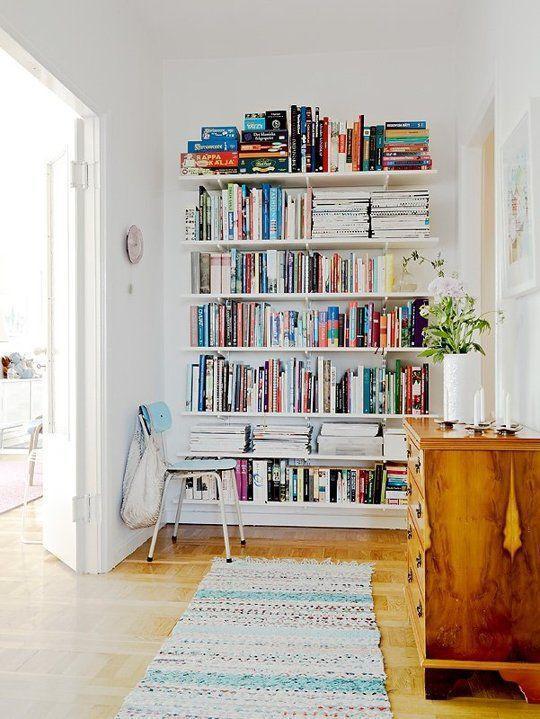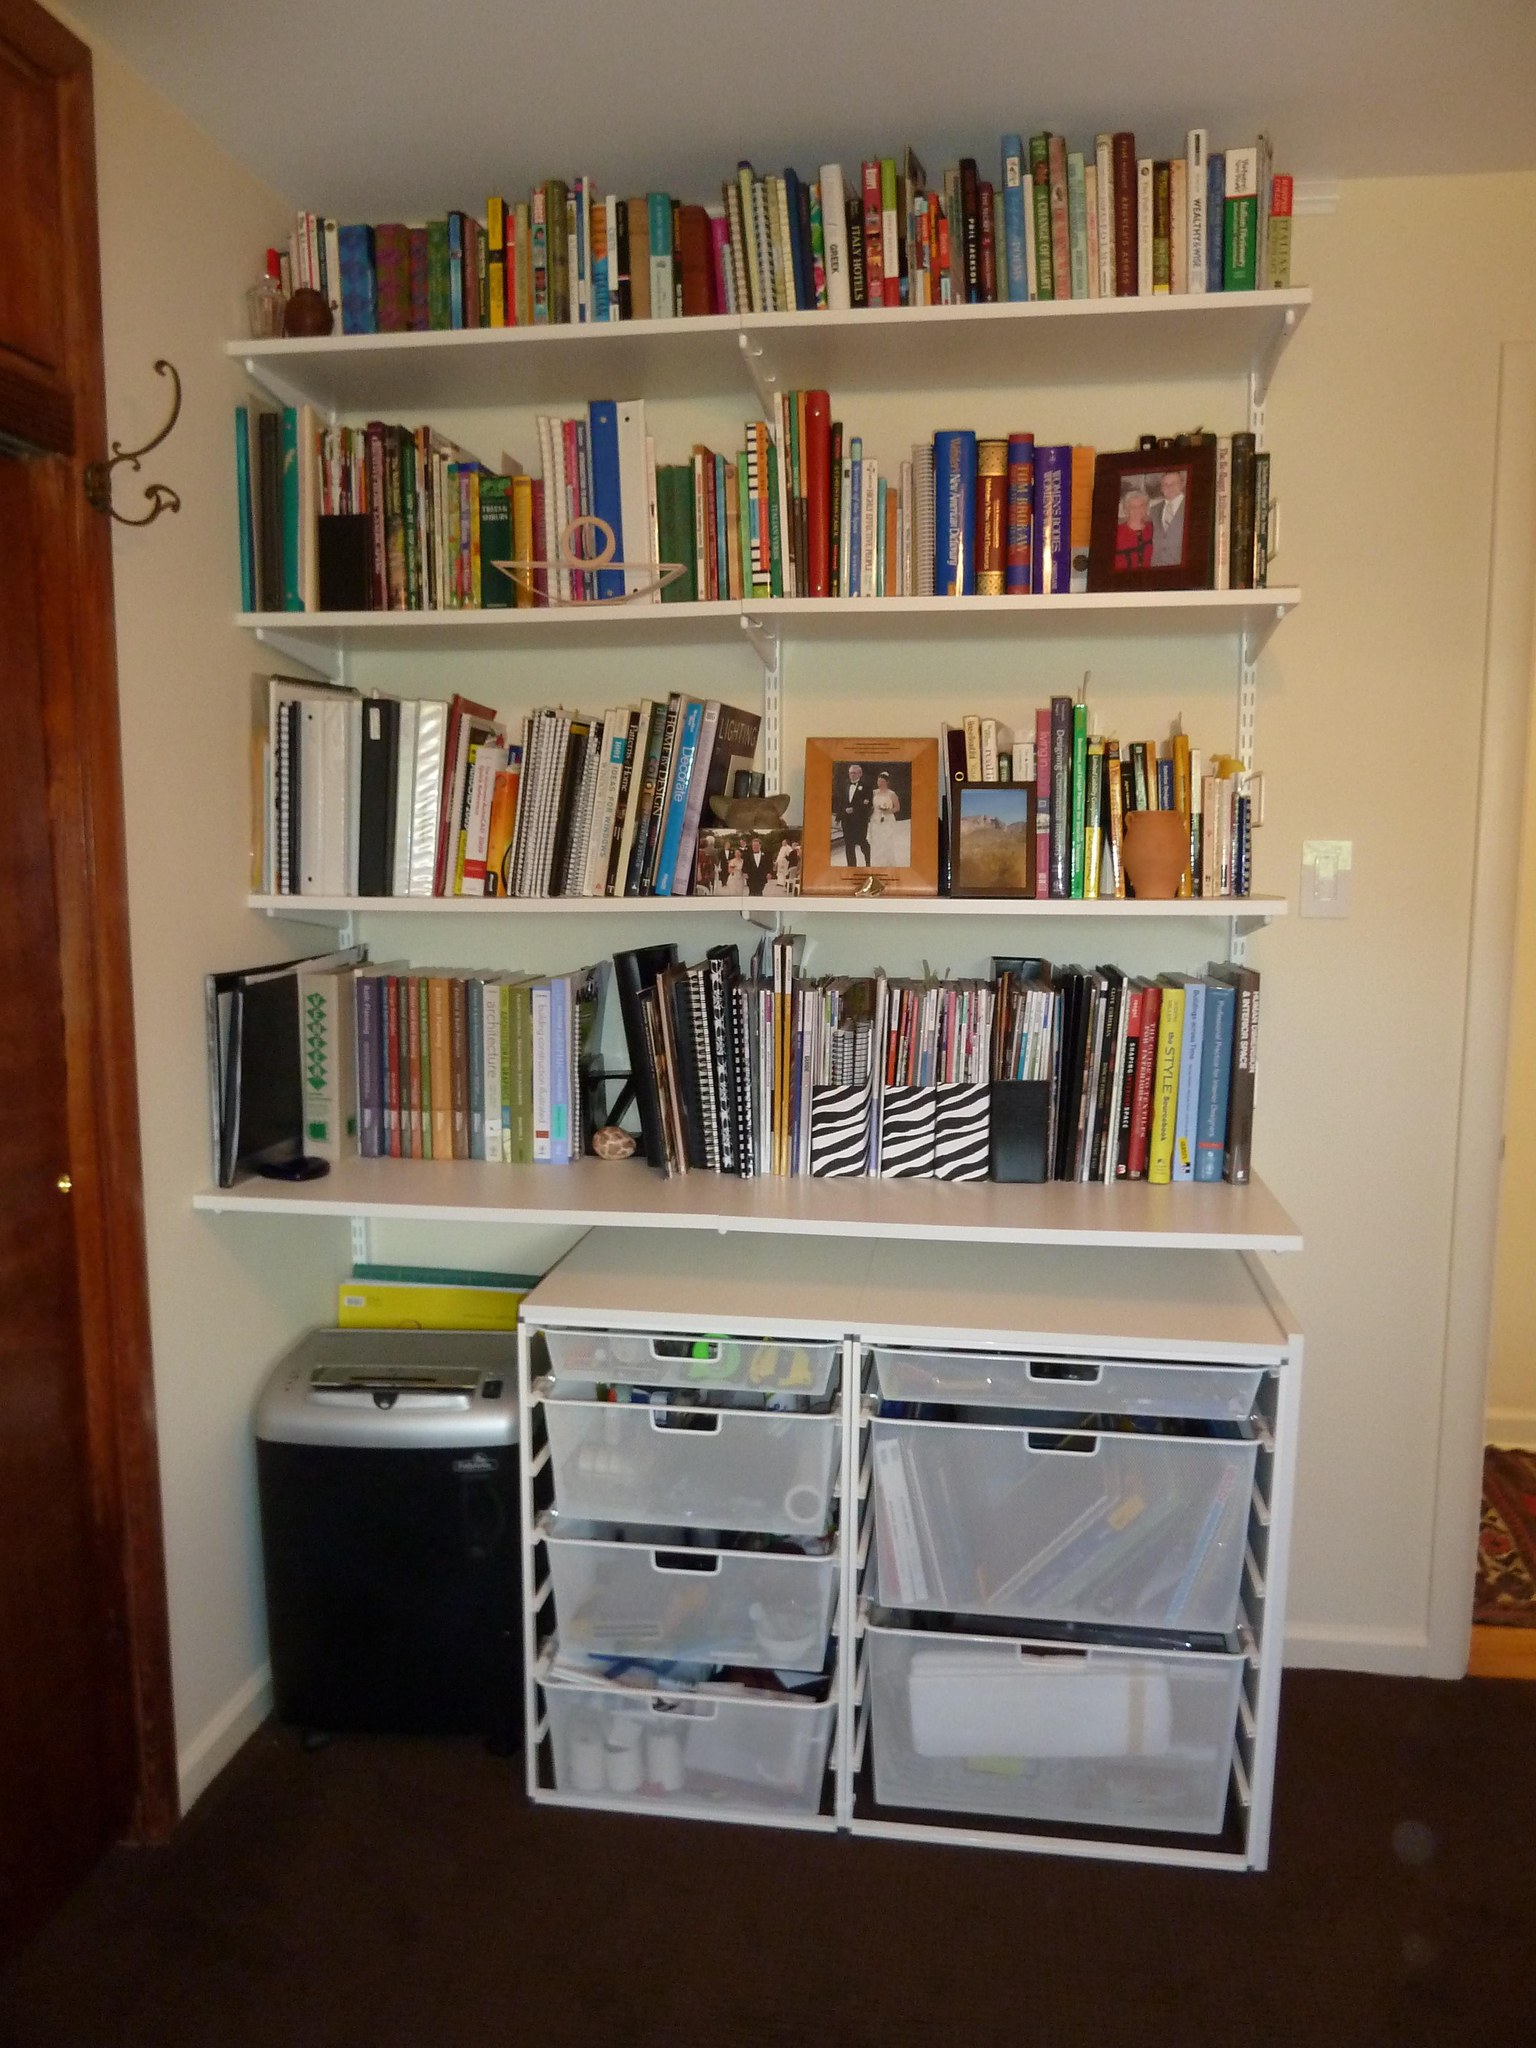The first image is the image on the left, the second image is the image on the right. Given the left and right images, does the statement "Both images show some type of floating white bookshelves that mount to the wall." hold true? Answer yes or no. Yes. The first image is the image on the left, the second image is the image on the right. Considering the images on both sides, is "There is at least one plant in the pair of images." valid? Answer yes or no. Yes. 